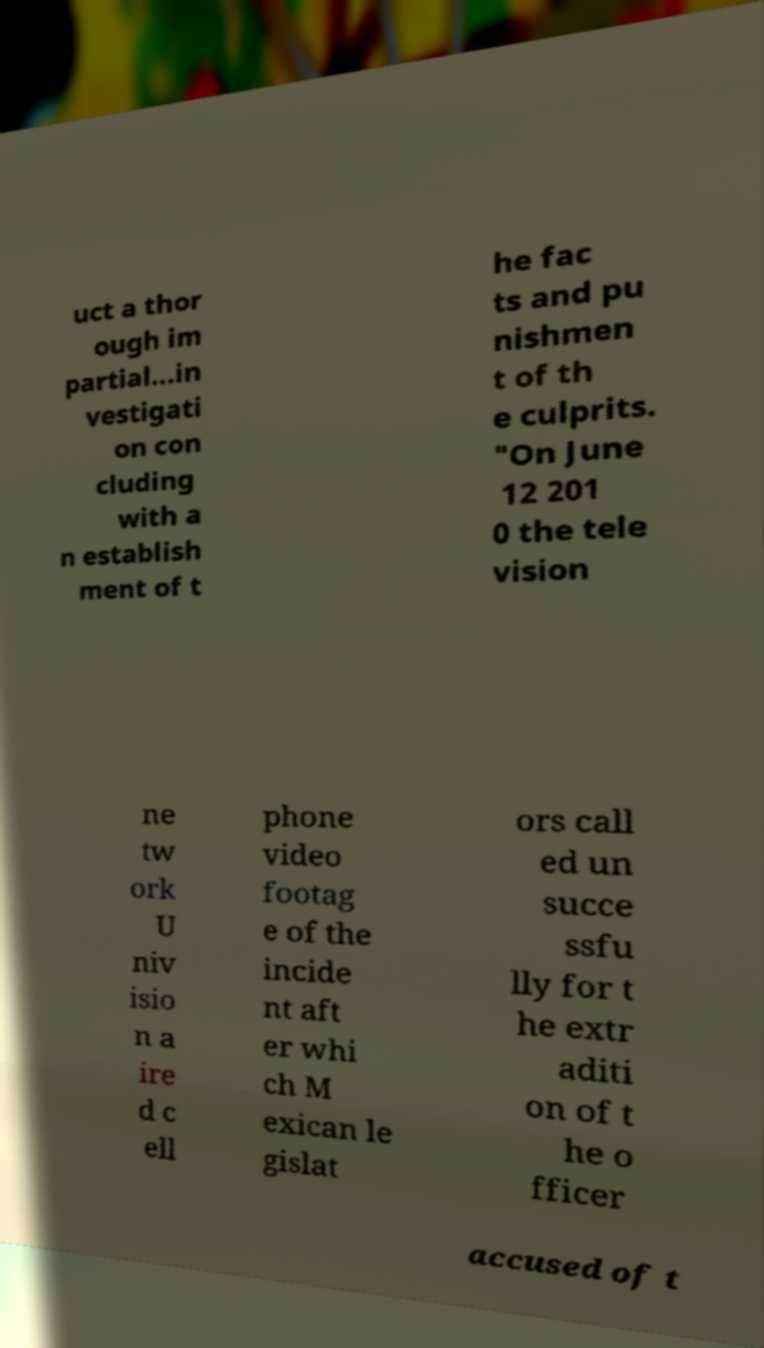Can you read and provide the text displayed in the image?This photo seems to have some interesting text. Can you extract and type it out for me? uct a thor ough im partial...in vestigati on con cluding with a n establish ment of t he fac ts and pu nishmen t of th e culprits. "On June 12 201 0 the tele vision ne tw ork U niv isio n a ire d c ell phone video footag e of the incide nt aft er whi ch M exican le gislat ors call ed un succe ssfu lly for t he extr aditi on of t he o fficer accused of t 